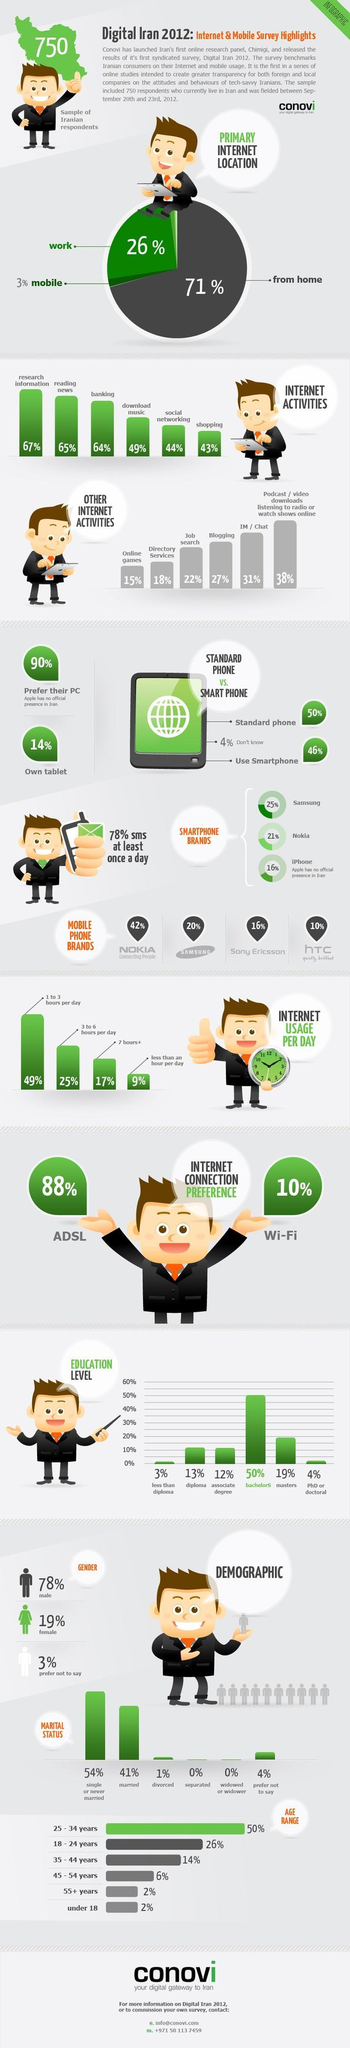What percentage of users in Iran use mobile for internet activities, 67%, 65%, or 64%?
Answer the question with a short phrase. 65% Which category of people use the second least percentage of internet  based on their education? PhD or Doctoral Which is primary internet location for most users, work, home, or mobile? home What is the percentage of users using internet for 3 to 6 hours? 25% What percentage of users in Iran use internet for chatting, 27%, 31%, or 38%? 31% What percentage of widowed or separated people use internet ? 0% Which age groups have only 2% internet usage? 55+ years, under 18 Which is the mobile phone brand is used by 20% of users? Samsung 